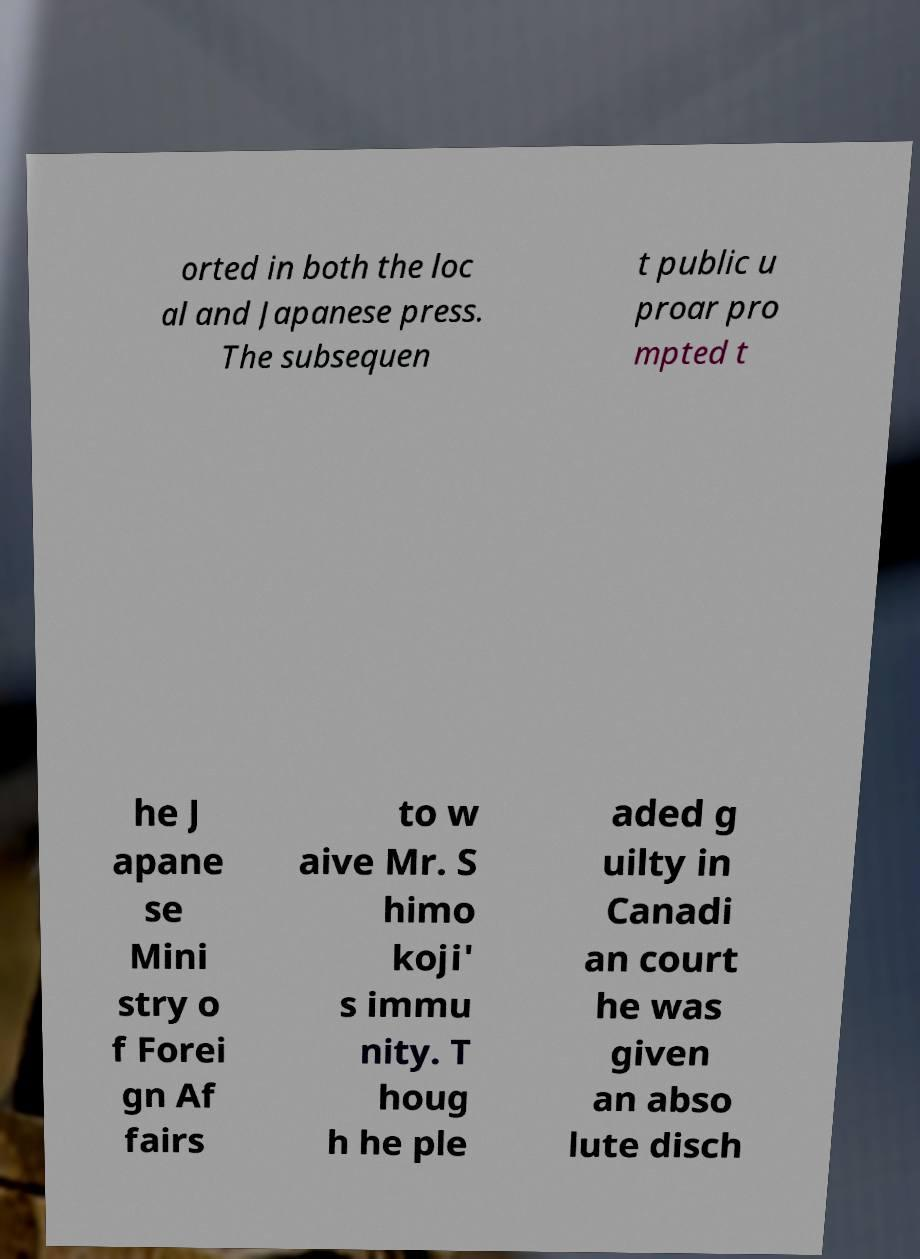Can you accurately transcribe the text from the provided image for me? orted in both the loc al and Japanese press. The subsequen t public u proar pro mpted t he J apane se Mini stry o f Forei gn Af fairs to w aive Mr. S himo koji' s immu nity. T houg h he ple aded g uilty in Canadi an court he was given an abso lute disch 